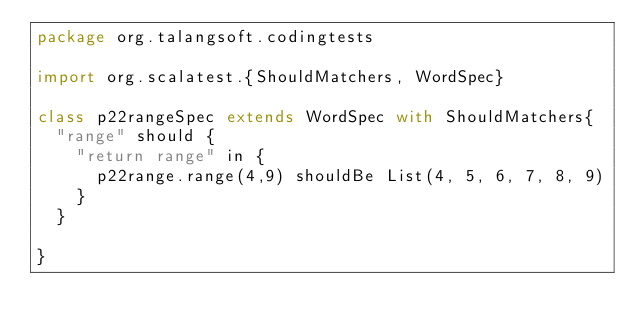<code> <loc_0><loc_0><loc_500><loc_500><_Scala_>package org.talangsoft.codingtests

import org.scalatest.{ShouldMatchers, WordSpec}

class p22rangeSpec extends WordSpec with ShouldMatchers{
  "range" should {
    "return range" in {
      p22range.range(4,9) shouldBe List(4, 5, 6, 7, 8, 9)
    }
  }

}
</code> 